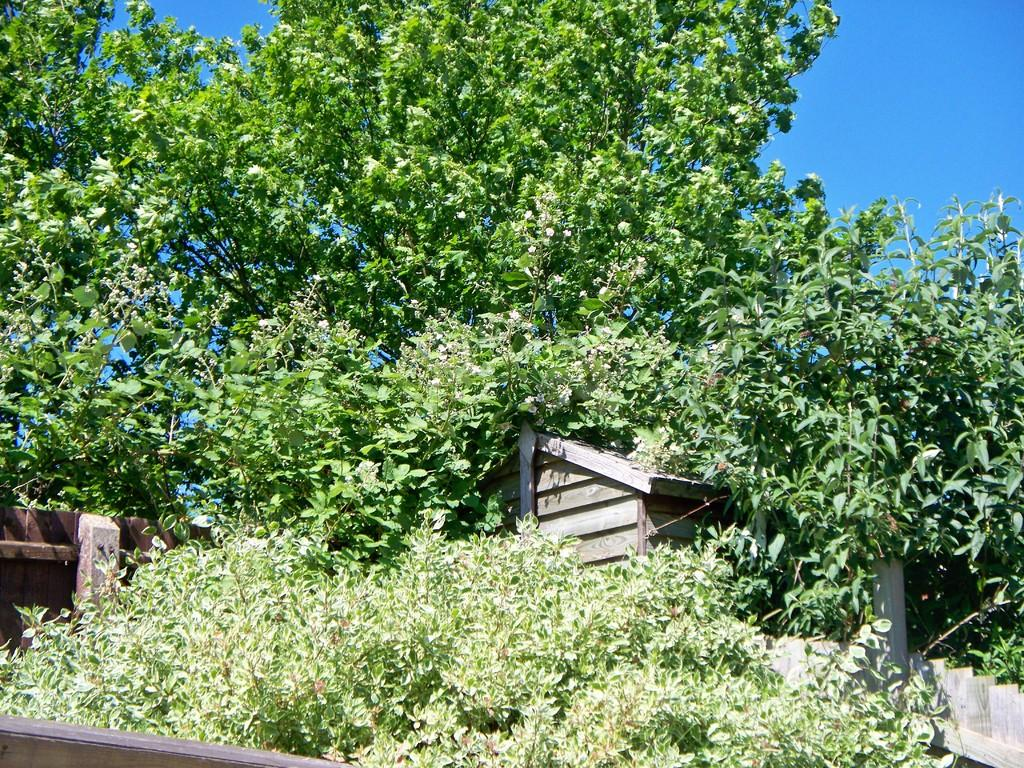What type of vegetation is present in the image? There are plants and trees in the image. What type of structure can be seen in the image? There is a wooden shed in the image. What is visible in the background of the image? The sky is visible in the background of the image. Can you tell me how many requests are being made by the banana in the image? There is no banana present in the image, and therefore no requests can be observed. What type of sponge is being used to clean the wooden shed in the image? There is no sponge visible in the image, and the wooden shed does not appear to be in the process of being cleaned. 